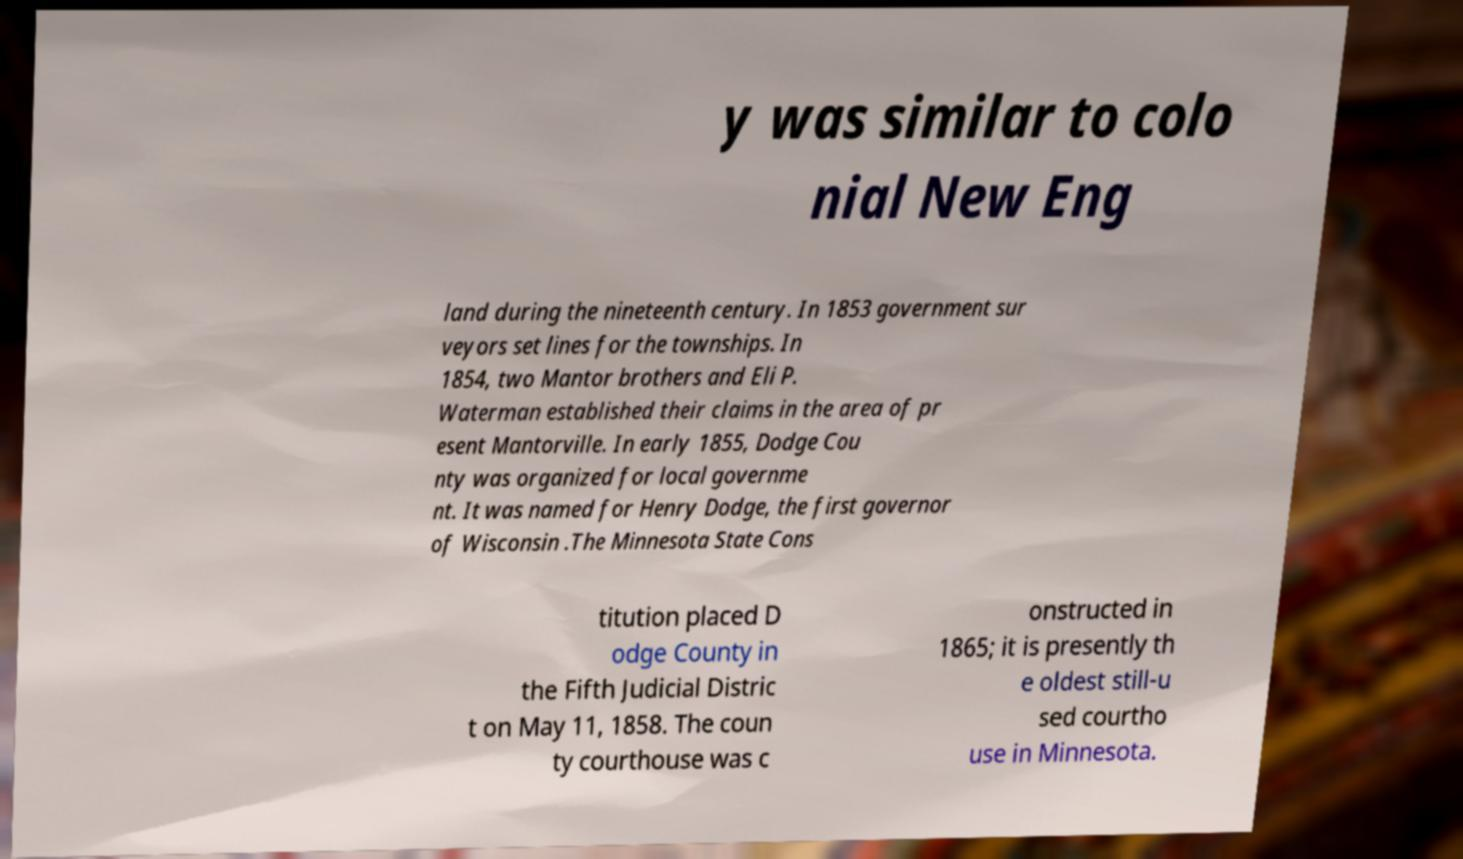For documentation purposes, I need the text within this image transcribed. Could you provide that? y was similar to colo nial New Eng land during the nineteenth century. In 1853 government sur veyors set lines for the townships. In 1854, two Mantor brothers and Eli P. Waterman established their claims in the area of pr esent Mantorville. In early 1855, Dodge Cou nty was organized for local governme nt. It was named for Henry Dodge, the first governor of Wisconsin .The Minnesota State Cons titution placed D odge County in the Fifth Judicial Distric t on May 11, 1858. The coun ty courthouse was c onstructed in 1865; it is presently th e oldest still-u sed courtho use in Minnesota. 